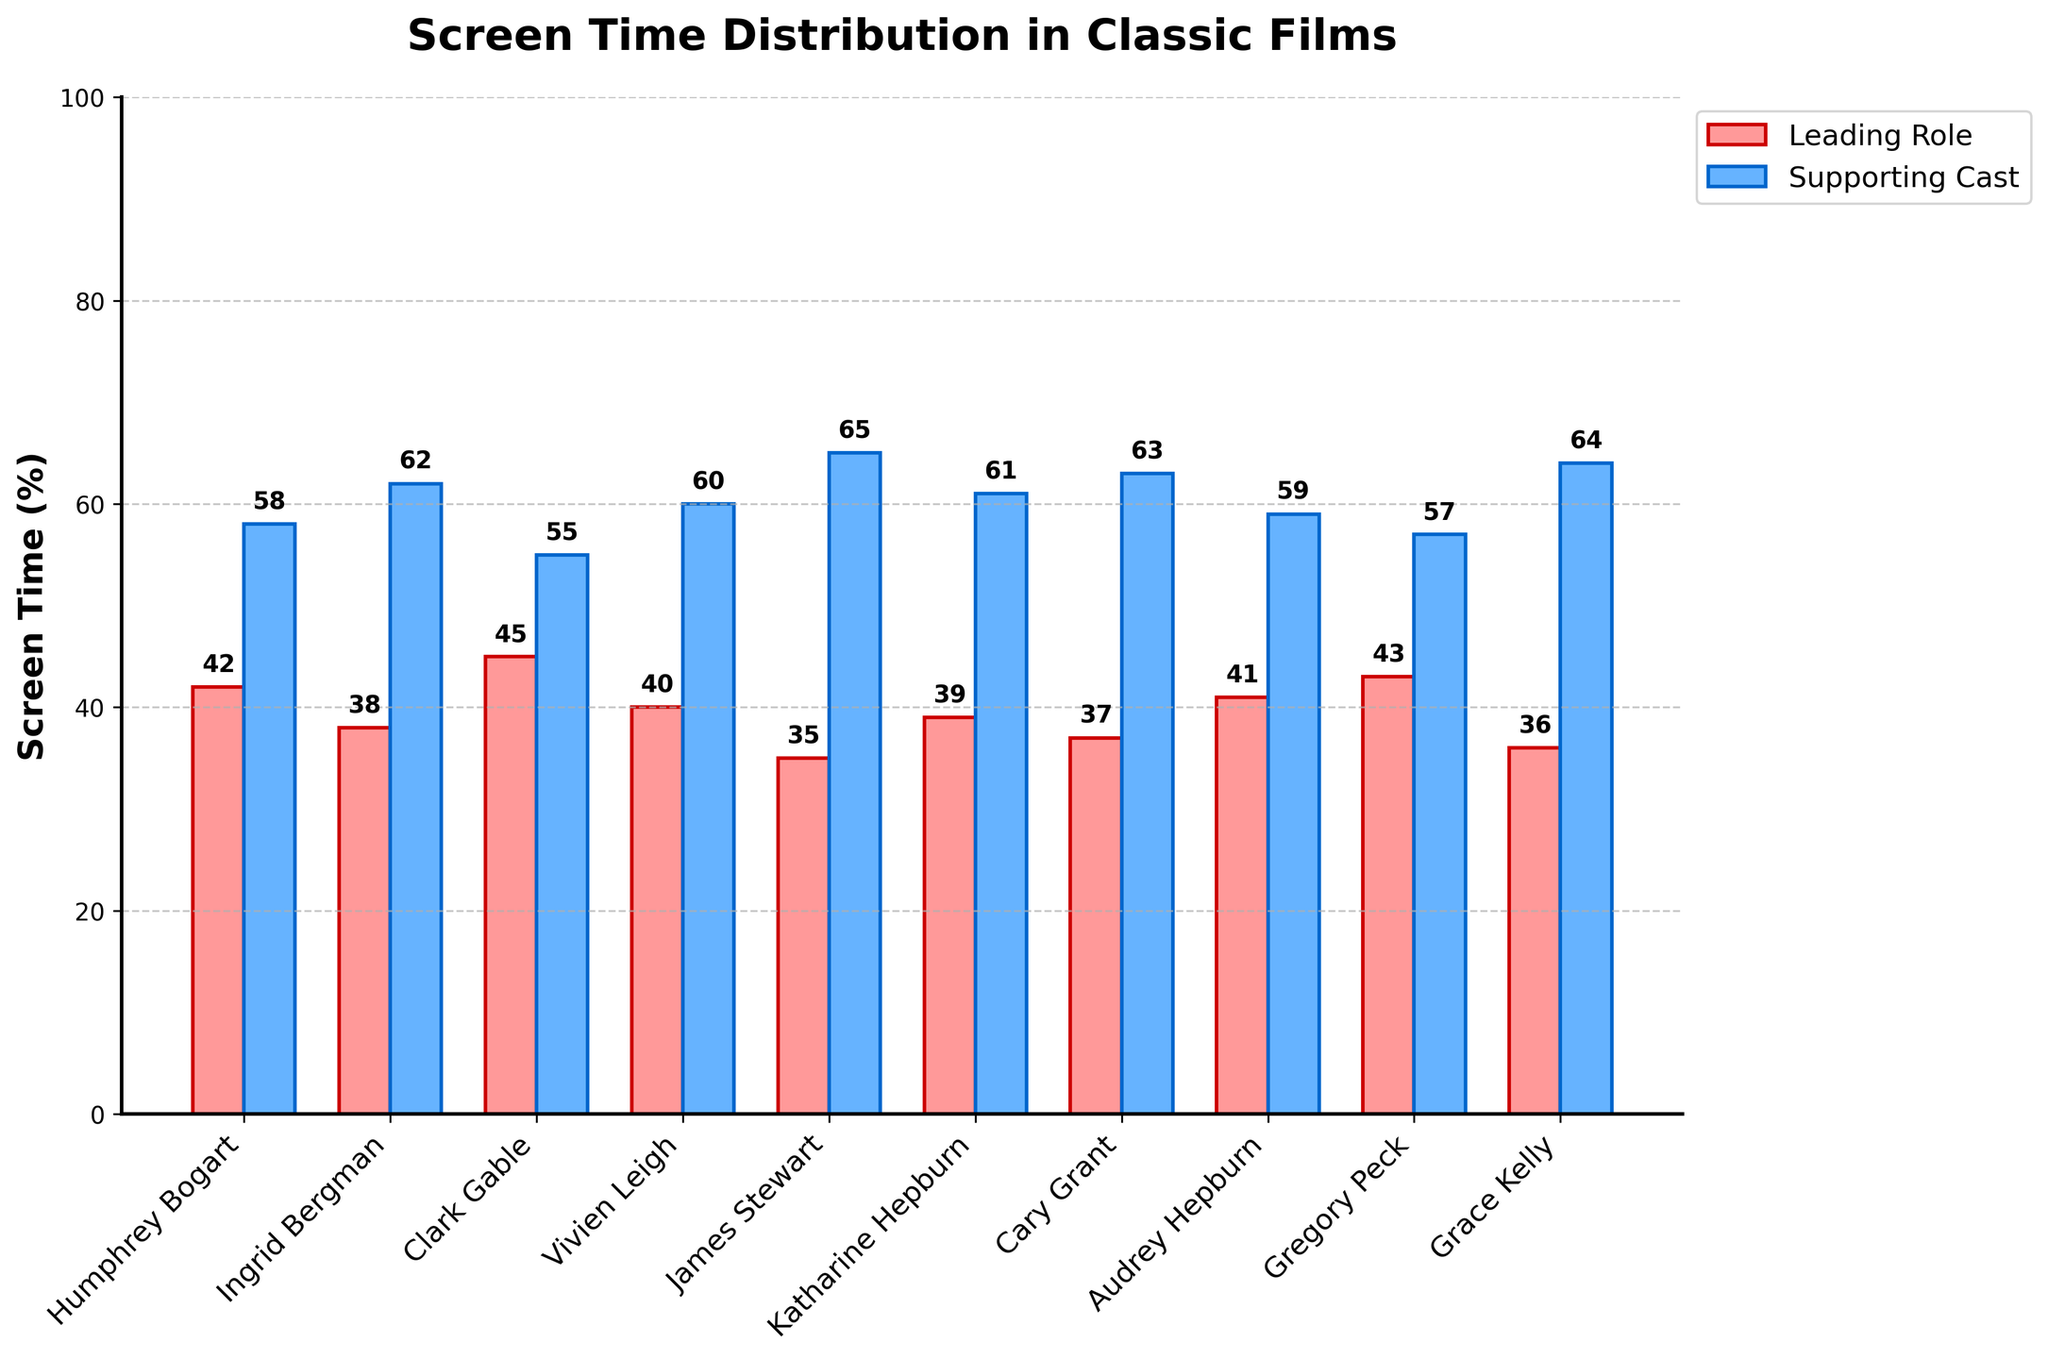Which actor has the highest leading role screen time? The bar representing Gregory Peck's leading role screen time is the tallest, with a value of 43%.
Answer: Gregory Peck Compare Ingrid Bergman's and Clark Gable's leading role screen times. Who has more? Clark Gable's leading role screen time bar is slightly taller than Ingrid Bergman's, with values of 45% and 38%, respectively.
Answer: Clark Gable What is the total screen time percentage of the leading roles for Katharine Hepburn, Cary Grant, and Humphrey Bogart? Katharine Hepburn has 39%, Cary Grant has 37%, and Humphrey Bogart has 42%. Summing these gives 39% + 37% + 42% = 118%.
Answer: 118% Which actors have the same supporting cast screen time as leading role screen time (35% or 36%)? James Stewart's leading role screen time is 35%, and Grace Kelly's leading role screen time is 36%. Their supporting cast screen time is 65% and 64%, respectively. None of the actors have the same supporting and leading role times.
Answer: None What is the range of leading role screen time percentages? The leading role screen time percentages range from the lowest (35% by James Stewart) to the highest (45% by Clark Gable), so the range is 45% - 35% = 10%.
Answer: 10% Compare the supporting cast screen time for James Stewart and Grace Kelly. Who has a larger share? Grace Kelly's supporting cast screen time is slightly taller than James Stewart's, with values of 64% and 65%, respectively.
Answer: James Stewart Is there any actor whose leading role screen time is below 40%? If yes, name them. The leading role screen time for James Stewart is 35%, Katharine Hepburn is 39%, Cary Grant is 37%, Grace Kelly is 36%, and Ingrid Bergman is 38%.
Answer: James Stewart, Katharine Hepburn, Cary Grant, Grace Kelly, Ingrid Bergman What is the difference between Gregory Peck's and Audrey Hepburn's leading role screen time? Gregory Peck's leading role screen time is 43%, and Audrey Hepburn's is 41%. The difference is 43% - 41% = 2%.
Answer: 2% Which actor has the least screen time in leading roles among the given data? The shortest bar for leading role screen time belongs to James Stewart, at 35%.
Answer: James Stewart What are the average percentages of leading role and supporting cast screen times across all actors? Summing the leading role screen times: 42 + 38 + 45 + 40 + 35 + 39 + 37 + 41 + 43 + 36 = 396. The average leading role screen time is 396/10 = 39.6%. Similarly, summing the supporting cast screen times: 58 + 62 + 55 + 60 + 65 + 61 + 63 + 59 + 57 + 64 = 604. The average supporting cast screen time is 604/10 = 60.4%.
Answer: Leading Role: 39.6%, Supporting Cast: 60.4% 